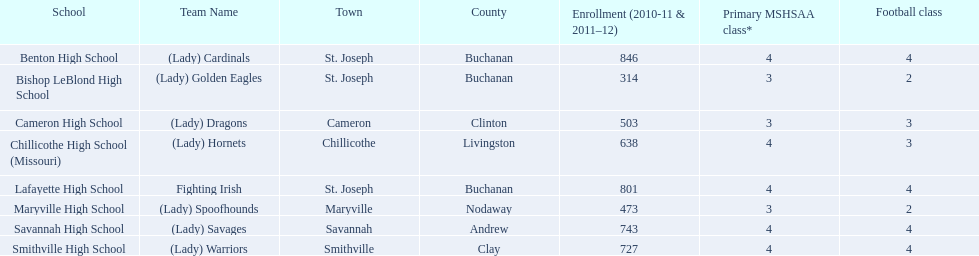Which educational institution in the midland empire conference has an enrollment of 846 students? Benton High School. Which one has 314 students? Bishop LeBlond High School. And which one has 638 students? Chillicothe High School (Missouri). 